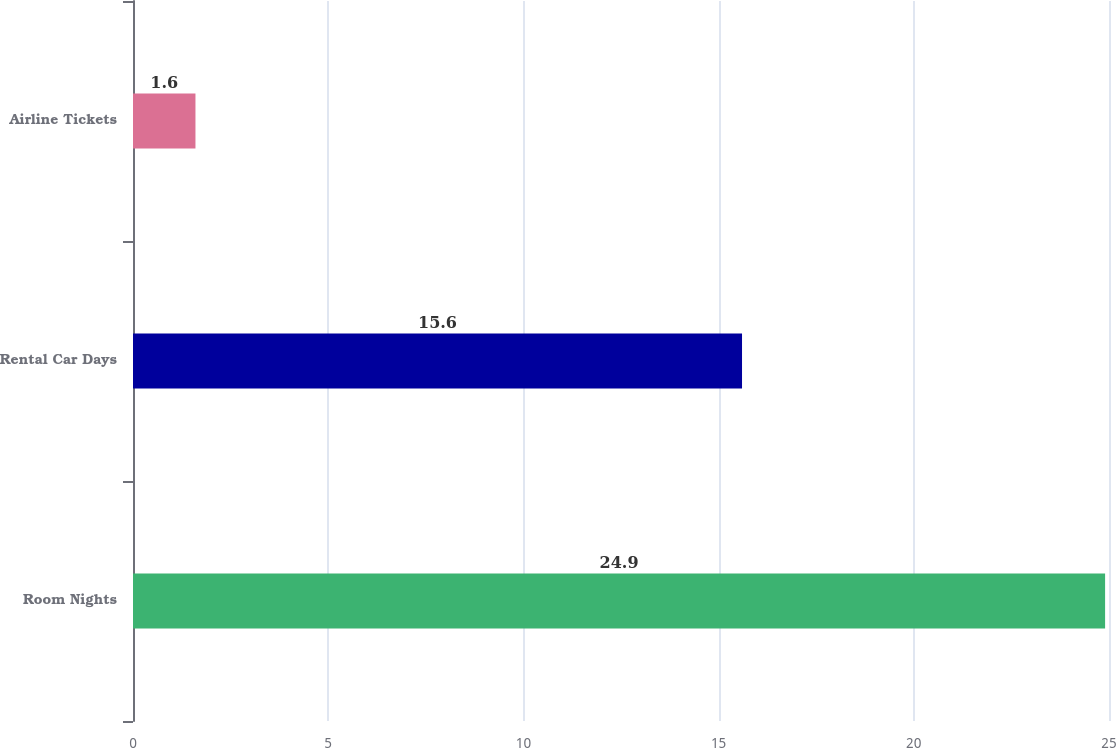Convert chart to OTSL. <chart><loc_0><loc_0><loc_500><loc_500><bar_chart><fcel>Room Nights<fcel>Rental Car Days<fcel>Airline Tickets<nl><fcel>24.9<fcel>15.6<fcel>1.6<nl></chart> 